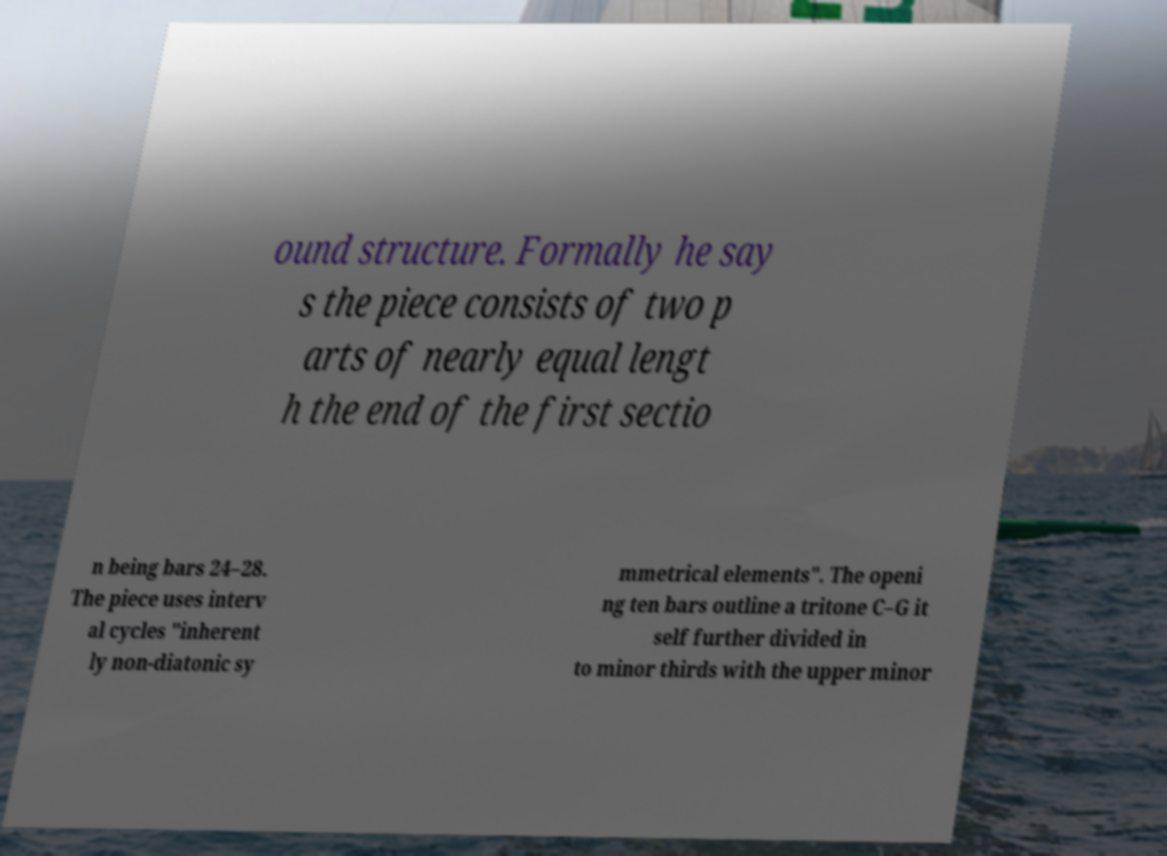For documentation purposes, I need the text within this image transcribed. Could you provide that? ound structure. Formally he say s the piece consists of two p arts of nearly equal lengt h the end of the first sectio n being bars 24–28. The piece uses interv al cycles "inherent ly non-diatonic sy mmetrical elements". The openi ng ten bars outline a tritone C–G it self further divided in to minor thirds with the upper minor 